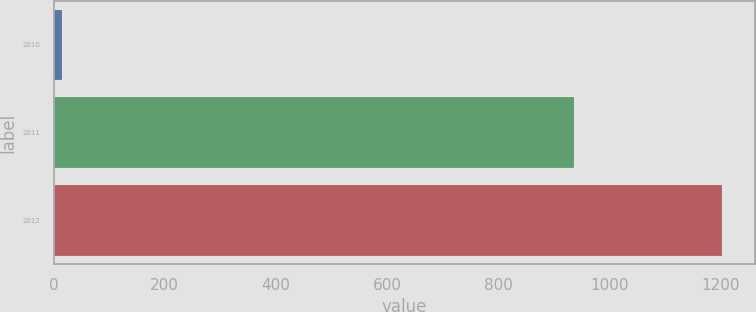<chart> <loc_0><loc_0><loc_500><loc_500><bar_chart><fcel>2010<fcel>2011<fcel>2012<nl><fcel>15<fcel>936<fcel>1203<nl></chart> 